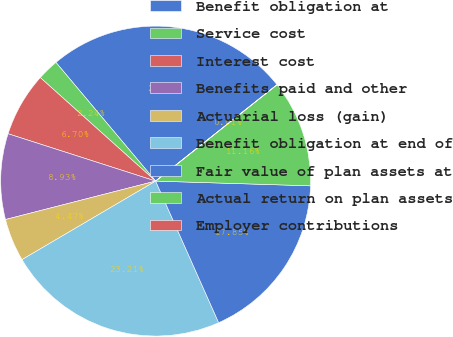Convert chart. <chart><loc_0><loc_0><loc_500><loc_500><pie_chart><fcel>Benefit obligation at<fcel>Service cost<fcel>Interest cost<fcel>Benefits paid and other<fcel>Actuarial loss (gain)<fcel>Benefit obligation at end of<fcel>Fair value of plan assets at<fcel>Actual return on plan assets<fcel>Employer contributions<nl><fcel>25.44%<fcel>2.24%<fcel>6.7%<fcel>8.93%<fcel>4.47%<fcel>23.21%<fcel>17.85%<fcel>11.16%<fcel>0.01%<nl></chart> 